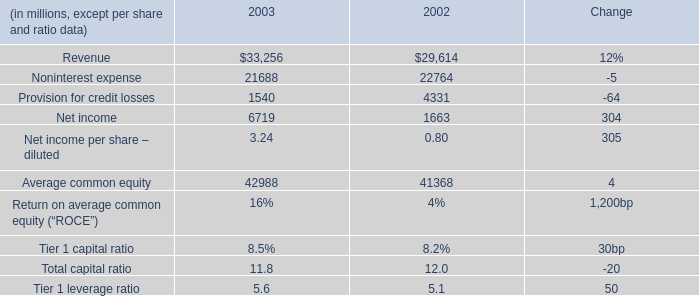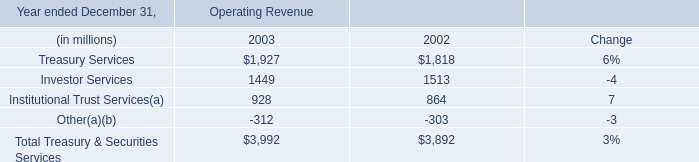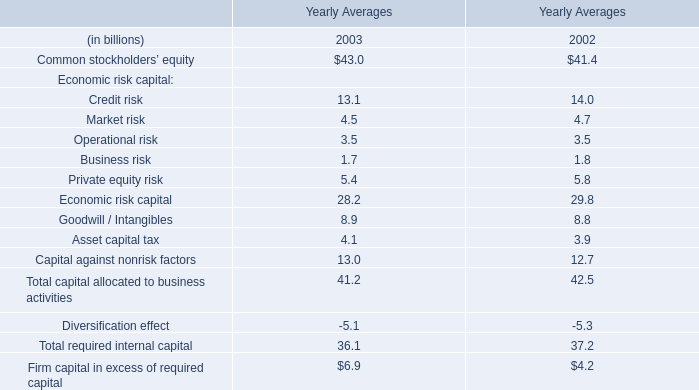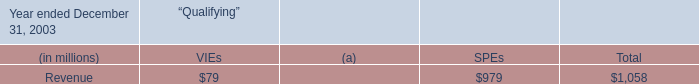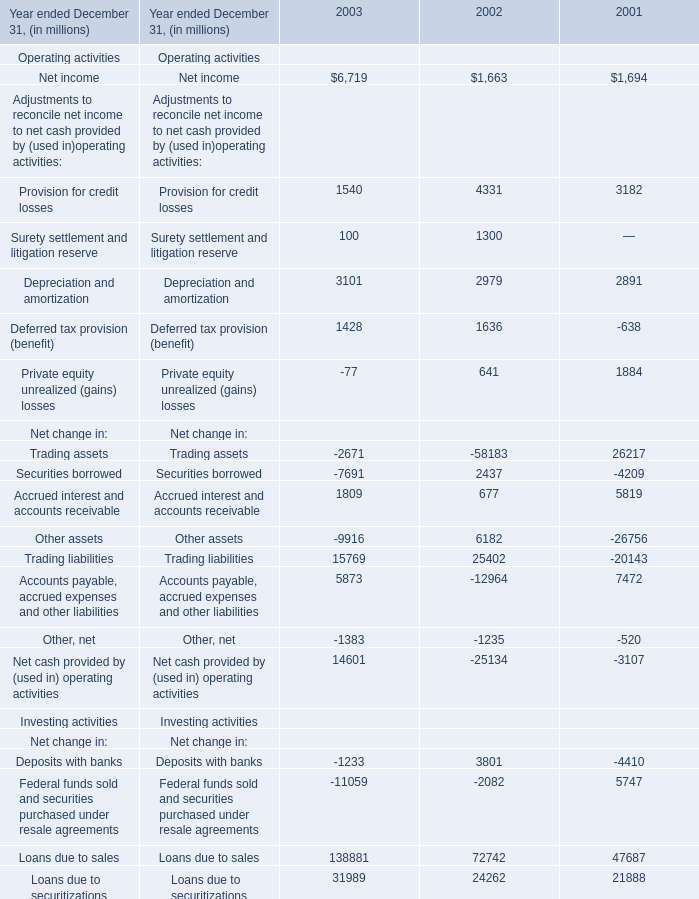What's the total amount of the Provision for credit losses in the years where Net income greater than 6000? (in million) 
Answer: 1540. 